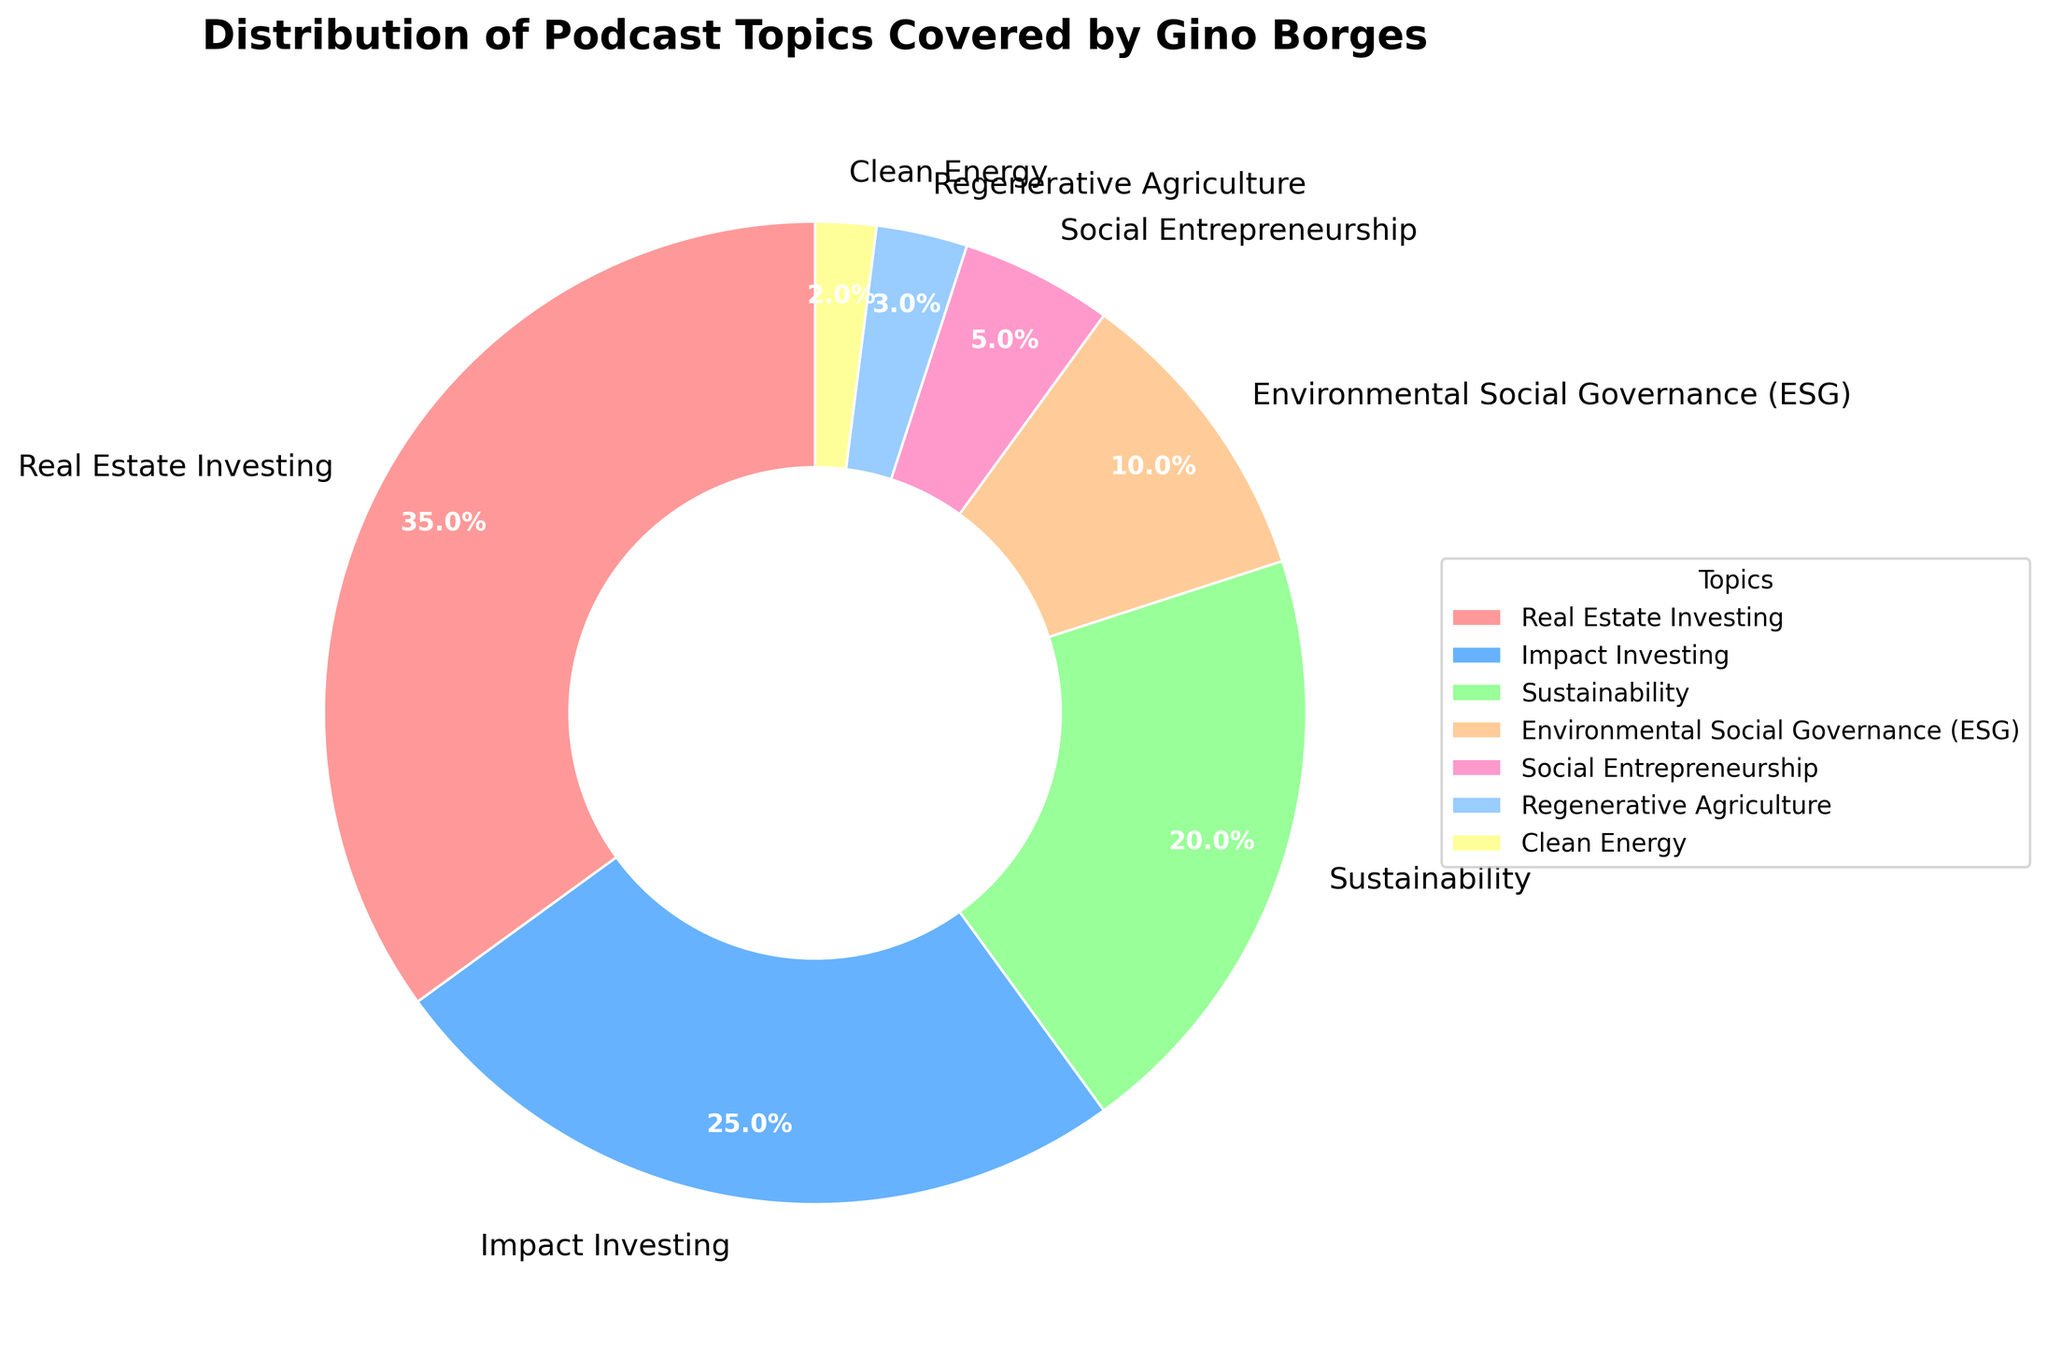What is the largest topic covered by Gino Borges' podcasts? The largest slice of the pie chart represents Real Estate Investing, which accounts for 35% of the topics covered.
Answer: Real Estate Investing Which topic has the smallest percentage in the pie chart? The smallest slice of the pie chart represents Clean Energy, with 2%.
Answer: Clean Energy What is the combined percentage of Impact Investing and Sustainability topics? Impact Investing accounts for 25%, and Sustainability accounts for 20%. Adding them together gives 25% + 20% = 45%.
Answer: 45% How does the percentage of Environmental Social Governance (ESG) compare to Social Entrepreneurship? ESG represents 10%, while Social Entrepreneurship represents 5%. ESG is twice as large as Social Entrepreneurship.
Answer: ESG is twice as large Which topic has a larger percentage: Regenerative Agriculture or Clean Energy? Regenerative Agriculture accounts for 3%, whereas Clean Energy accounts for 2%. Regenerative Agriculture has a larger percentage.
Answer: Regenerative Agriculture How many topics are covered more than 10% in the pie chart? Real Estate Investing (35%), Impact Investing (25%), and Sustainability (20%) are the topics that exceed 10%. There are 3 such topics.
Answer: 3 What is the total percentage of topics related to sustainability (including Environmental Social Governance and Clean Energy)? Sustainability accounts for 20%, Environmental Social Governance (ESG) accounts for 10%, and Clean Energy accounts for 2%. Adding them together gives 20% + 10% + 2% = 32%.
Answer: 32% What percentage covers the topic of Social Entrepreneurship relative to Real Estate Investing? Social Entrepreneurship represents 5%, and Real Estate Investing represents 35%. The relative percentage is calculated by (5/35) * 100 ≈ 14.3%.
Answer: 14.3% If you combine Real Estate Investing, Impact Investing, and Social Entrepreneurship, what is the total percentage? Real Estate Investing is 35%, Impact Investing is 25%, and Social Entrepreneurship is 5%. Adding them gives 35% + 25% + 5% = 65%.
Answer: 65% Which topic is represented by the green color in the pie chart? The pie chart assigns green to the Sustainability topic, which is shown in a distinct green slice.
Answer: Sustainability 